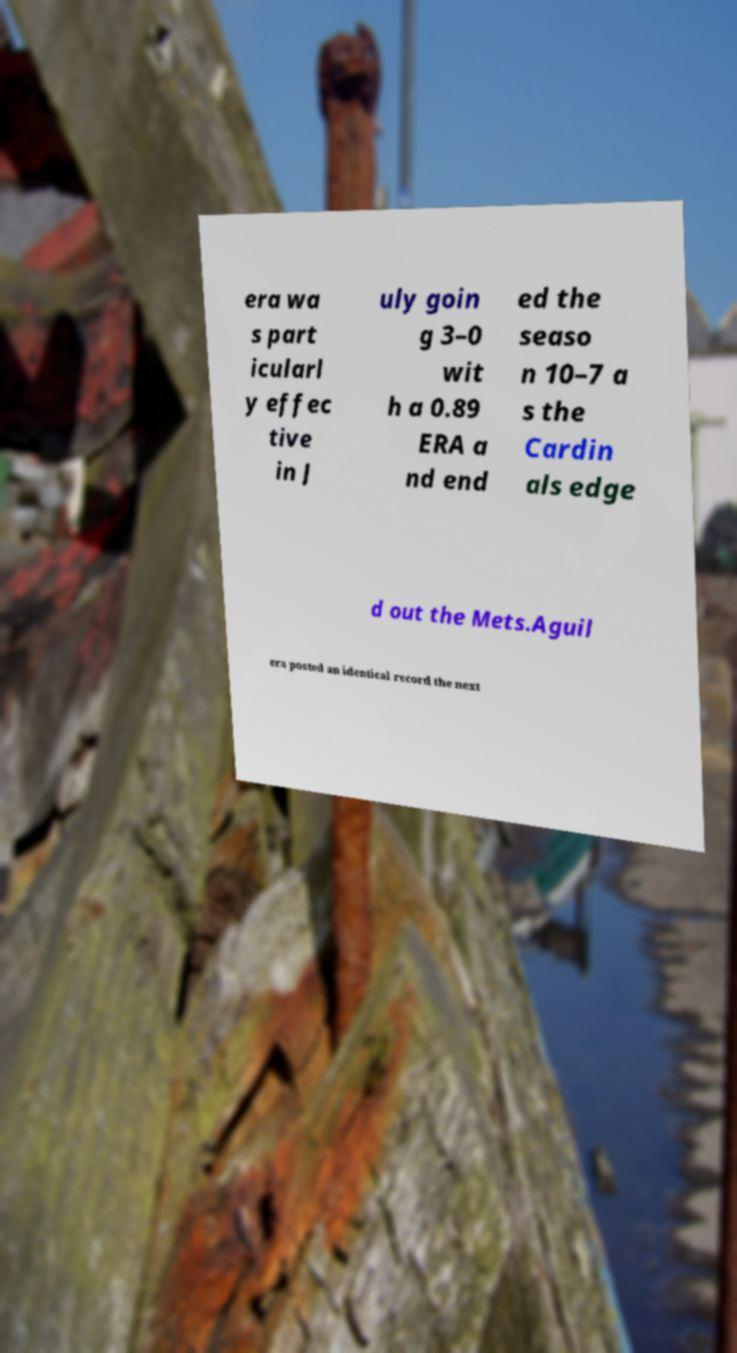What messages or text are displayed in this image? I need them in a readable, typed format. era wa s part icularl y effec tive in J uly goin g 3–0 wit h a 0.89 ERA a nd end ed the seaso n 10–7 a s the Cardin als edge d out the Mets.Aguil era posted an identical record the next 